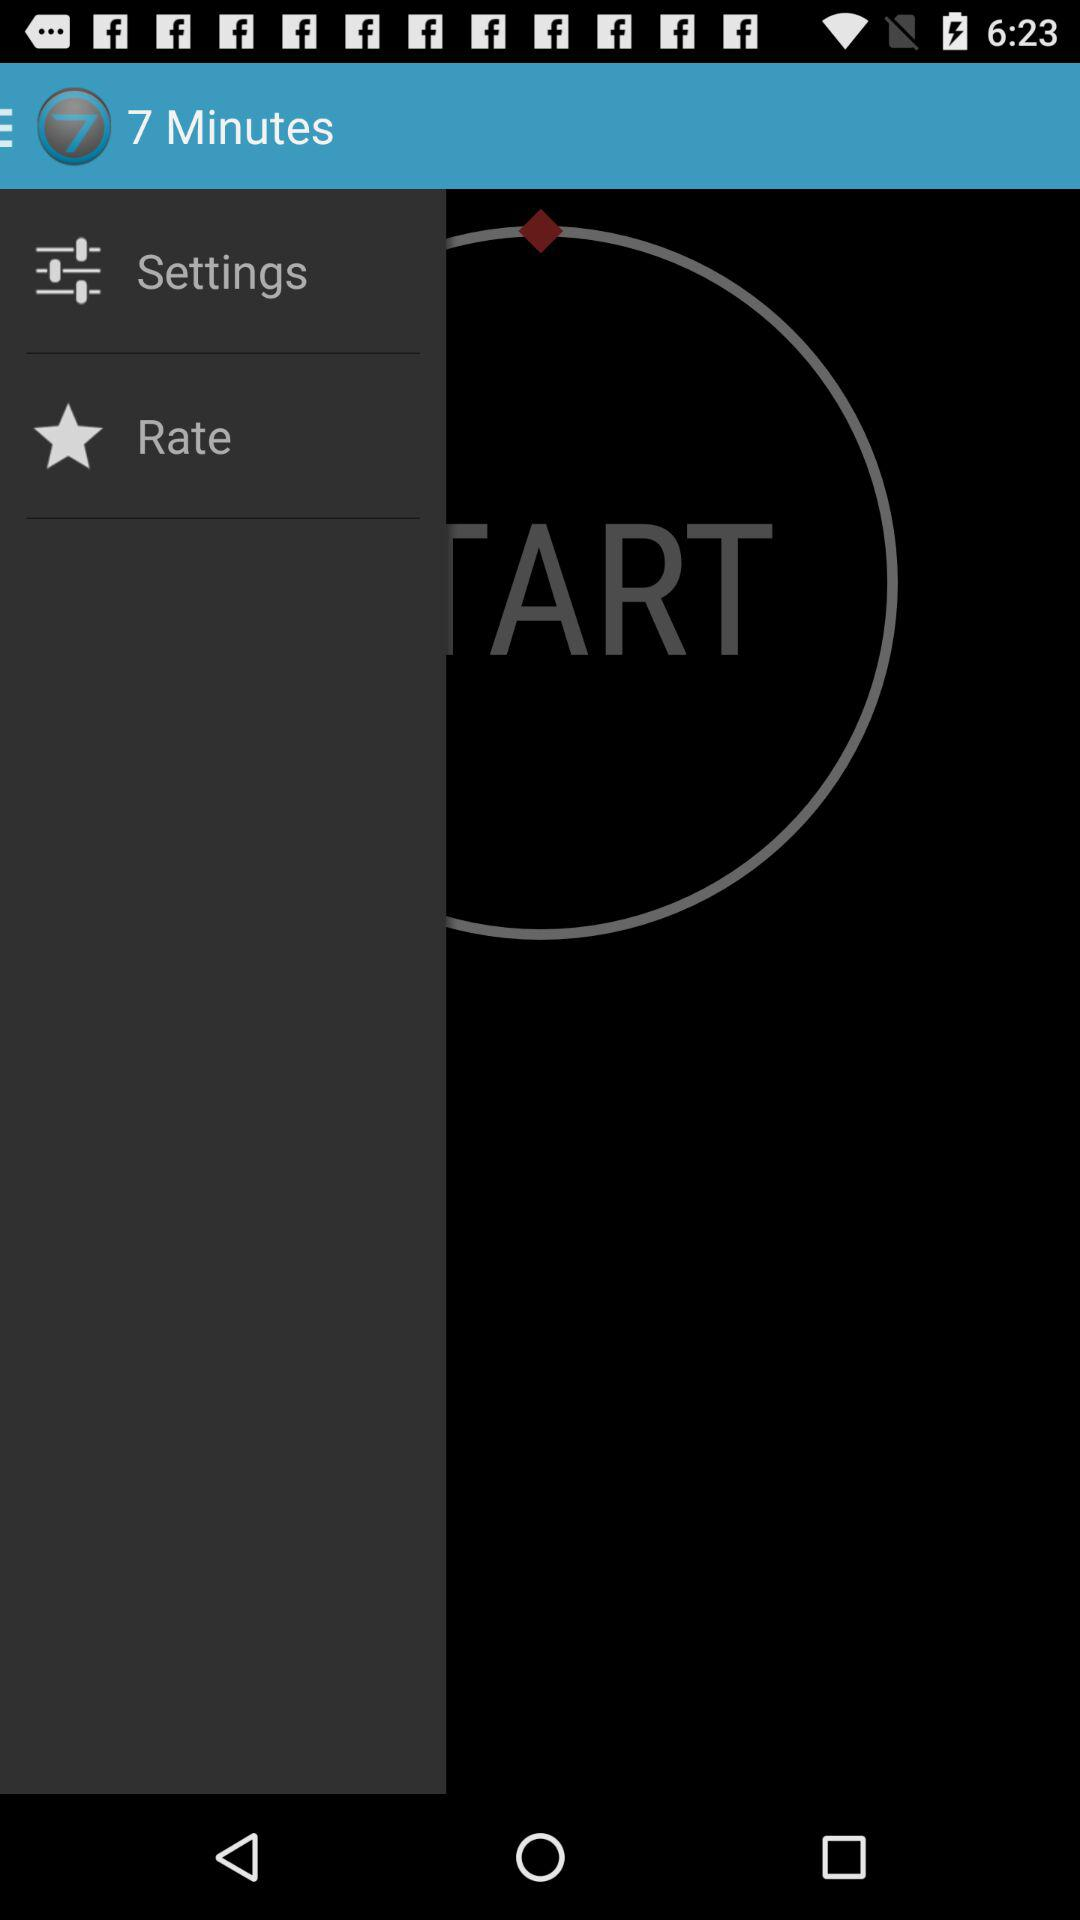What is the name of the application? The name of the application is "7 Minutes". 